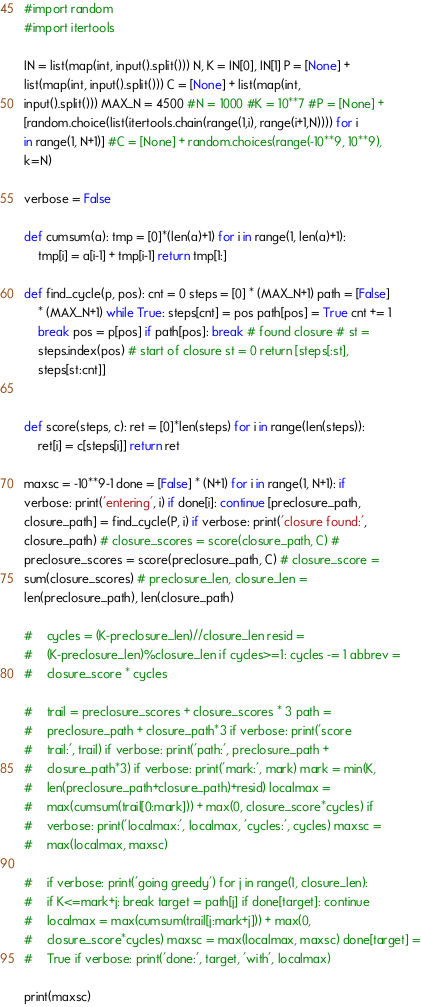Convert code to text. <code><loc_0><loc_0><loc_500><loc_500><_Python_>#import random
#import itertools

IN = list(map(int, input().split())) N, K = IN[0], IN[1] P = [None] +
list(map(int, input().split())) C = [None] + list(map(int,
input().split())) MAX_N = 4500 #N = 1000 #K = 10**7 #P = [None] +
[random.choice(list(itertools.chain(range(1,i), range(i+1,N)))) for i
in range(1, N+1)] #C = [None] + random.choices(range(-10**9, 10**9),
k=N)

verbose = False

def cumsum(a): tmp = [0]*(len(a)+1) for i in range(1, len(a)+1):
    tmp[i] = a[i-1] + tmp[i-1] return tmp[1:]

def find_cycle(p, pos): cnt = 0 steps = [0] * (MAX_N+1) path = [False]
    * (MAX_N+1) while True: steps[cnt] = pos path[pos] = True cnt += 1
    break pos = p[pos] if path[pos]: break # found closure # st =
    steps.index(pos) # start of closure st = 0 return [steps[:st],
    steps[st:cnt]]


def score(steps, c): ret = [0]*len(steps) for i in range(len(steps)):
    ret[i] = c[steps[i]] return ret

maxsc = -10**9-1 done = [False] * (N+1) for i in range(1, N+1): if
verbose: print('entering', i) if done[i]: continue [preclosure_path,
closure_path] = find_cycle(P, i) if verbose: print('closure found:',
closure_path) # closure_scores = score(closure_path, C) #
preclosure_scores = score(preclosure_path, C) # closure_score =
sum(closure_scores) # preclosure_len, closure_len =
len(preclosure_path), len(closure_path)

#    cycles = (K-preclosure_len)//closure_len resid =
#    (K-preclosure_len)%closure_len if cycles>=1: cycles -= 1 abbrev =
#    closure_score * cycles
   
#    trail = preclosure_scores + closure_scores * 3 path =
#    preclosure_path + closure_path*3 if verbose: print('score
#    trail:', trail) if verbose: print('path:', preclosure_path +
#    closure_path*3) if verbose: print('mark:', mark) mark = min(K,
#    len(preclosure_path+closure_path)+resid) localmax =
#    max(cumsum(trail[0:mark])) + max(0, closure_score*cycles) if
#    verbose: print('localmax:', localmax, 'cycles:', cycles) maxsc =
#    max(localmax, maxsc)

#    if verbose: print('going greedy') for j in range(1, closure_len):
#    if K<=mark+j: break target = path[j] if done[target]: continue
#    localmax = max(cumsum(trail[j:mark+j])) + max(0,
#    closure_score*cycles) maxsc = max(localmax, maxsc) done[target] =
#    True if verbose: print('done:', target, 'with', localmax)

print(maxsc)
</code> 